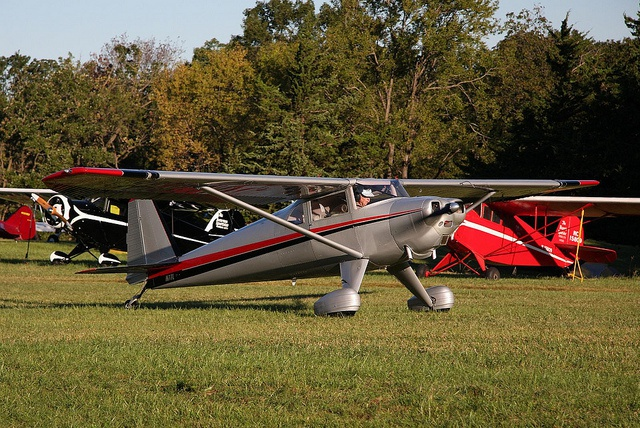Describe the objects in this image and their specific colors. I can see airplane in lightblue, black, gray, darkgray, and darkgreen tones, airplane in lightblue, black, red, maroon, and brown tones, airplane in lightblue, black, white, gray, and darkgreen tones, and people in lightblue, black, lightgray, and salmon tones in this image. 